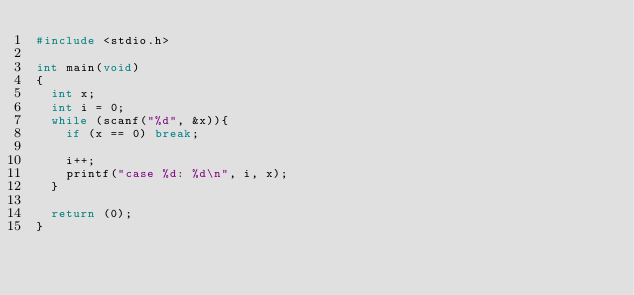Convert code to text. <code><loc_0><loc_0><loc_500><loc_500><_C_>#include <stdio.h>

int main(void)
{
	int x;
	int i = 0;
	while (scanf("%d", &x)){
		if (x == 0) break;
		
		i++;
		printf("case %d: %d\n", i, x);
	}
	
	return (0);
}</code> 